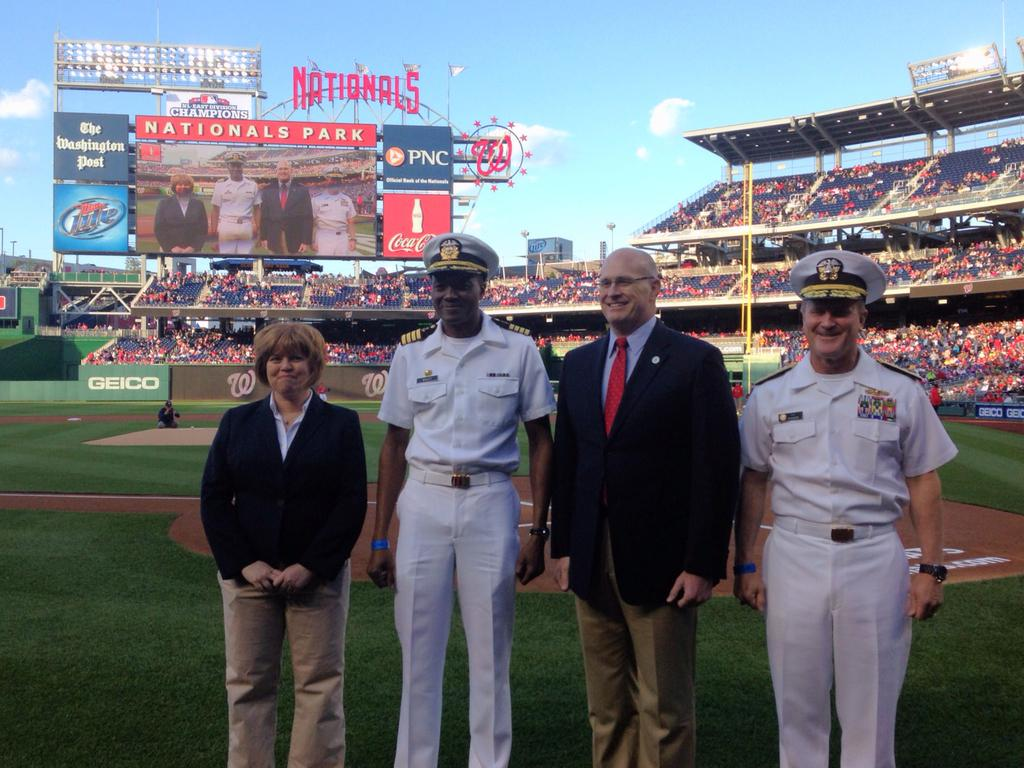<image>
Describe the image concisely. Two military officers and two civilians are lined up on the field at a Nationals baseball game. 